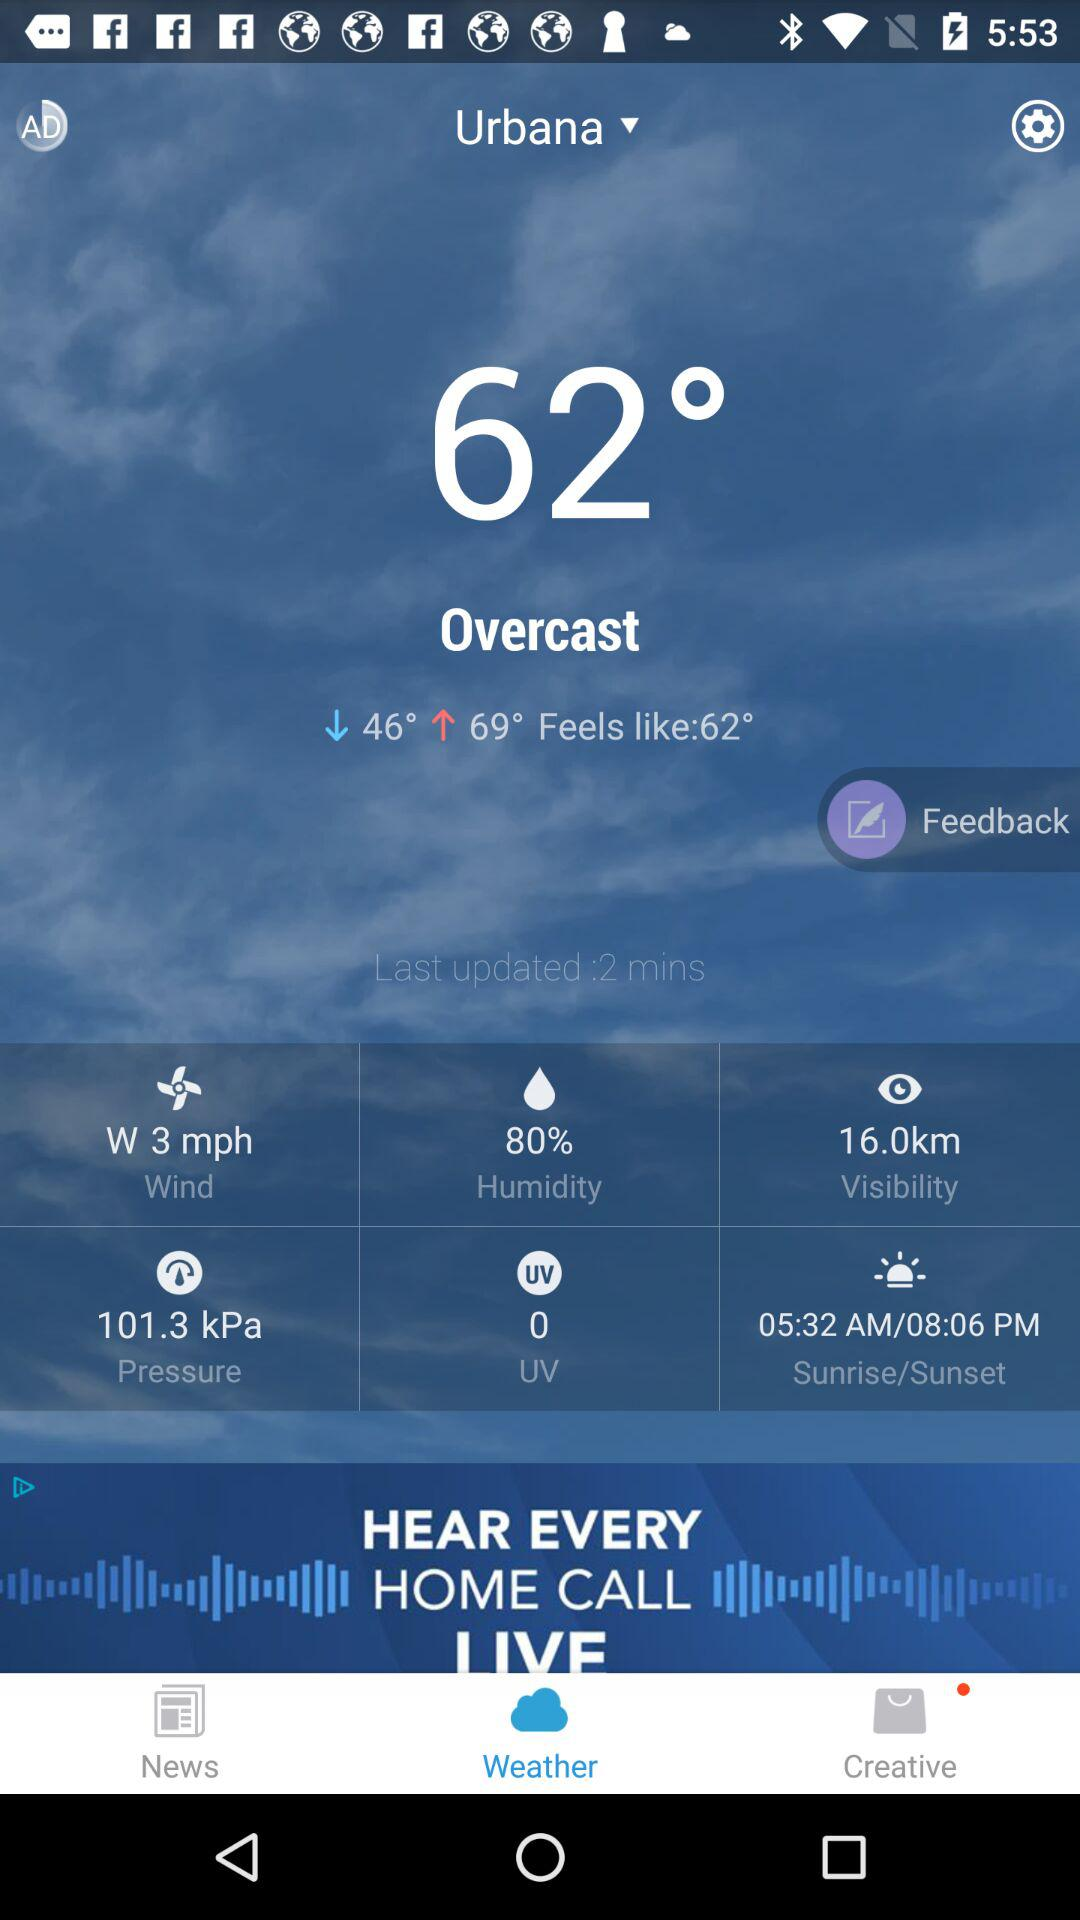What is the difference in degrees between the low and high temperatures?
Answer the question using a single word or phrase. 23 